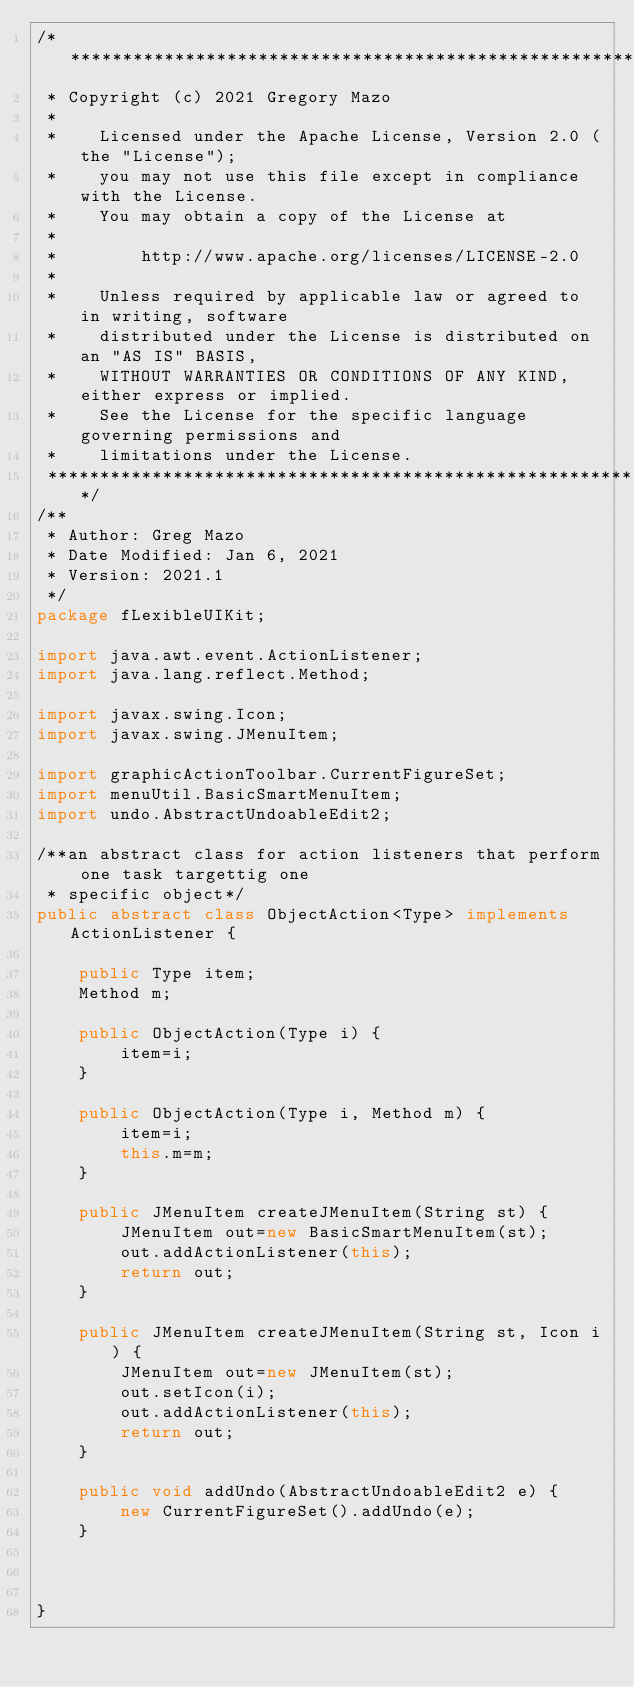<code> <loc_0><loc_0><loc_500><loc_500><_Java_>/*******************************************************************************
 * Copyright (c) 2021 Gregory Mazo
 *
 *    Licensed under the Apache License, Version 2.0 (the "License");
 *    you may not use this file except in compliance with the License.
 *    You may obtain a copy of the License at
 *
 *        http://www.apache.org/licenses/LICENSE-2.0
 *
 *    Unless required by applicable law or agreed to in writing, software
 *    distributed under the License is distributed on an "AS IS" BASIS,
 *    WITHOUT WARRANTIES OR CONDITIONS OF ANY KIND, either express or implied.
 *    See the License for the specific language governing permissions and
 *    limitations under the License.
 *******************************************************************************/
/**
 * Author: Greg Mazo
 * Date Modified: Jan 6, 2021
 * Version: 2021.1
 */
package fLexibleUIKit;

import java.awt.event.ActionListener;
import java.lang.reflect.Method;

import javax.swing.Icon;
import javax.swing.JMenuItem;

import graphicActionToolbar.CurrentFigureSet;
import menuUtil.BasicSmartMenuItem;
import undo.AbstractUndoableEdit2;

/**an abstract class for action listeners that perform one task targettig one
 * specific object*/
public abstract class ObjectAction<Type> implements ActionListener {
	
	public Type item;
	Method m;
	
	public ObjectAction(Type i) {
		item=i;
	}
	
	public ObjectAction(Type i, Method m) {
		item=i;
		this.m=m;
	}

	public JMenuItem createJMenuItem(String st) {
		JMenuItem out=new BasicSmartMenuItem(st);
		out.addActionListener(this);
		return out;
	}
	
	public JMenuItem createJMenuItem(String st, Icon i) {
		JMenuItem out=new JMenuItem(st);
		out.setIcon(i);
		out.addActionListener(this);
		return out;
	}
	
	public void addUndo(AbstractUndoableEdit2 e) {
		new CurrentFigureSet().addUndo(e);
	}
	
	

}
</code> 